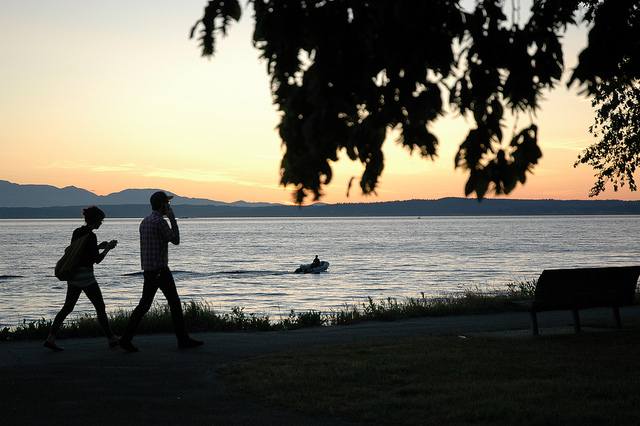<image>Have the people finished surfing? I am not sure if the people have finished surfing. Have the people finished surfing? I don't know if the people have finished surfing. It can be both yes and no. 